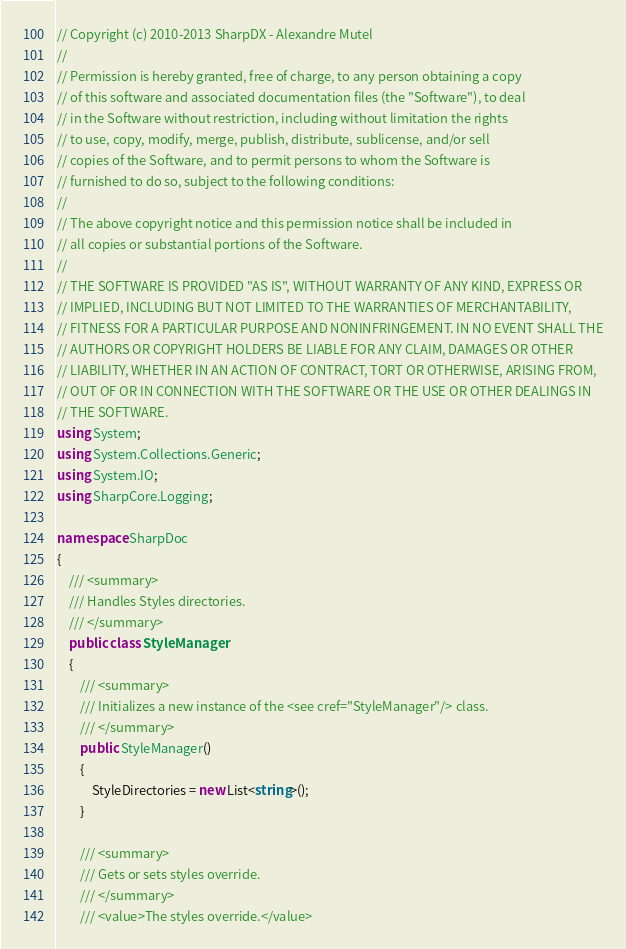Convert code to text. <code><loc_0><loc_0><loc_500><loc_500><_C#_>// Copyright (c) 2010-2013 SharpDX - Alexandre Mutel
// 
// Permission is hereby granted, free of charge, to any person obtaining a copy
// of this software and associated documentation files (the "Software"), to deal
// in the Software without restriction, including without limitation the rights
// to use, copy, modify, merge, publish, distribute, sublicense, and/or sell
// copies of the Software, and to permit persons to whom the Software is
// furnished to do so, subject to the following conditions:
// 
// The above copyright notice and this permission notice shall be included in
// all copies or substantial portions of the Software.
// 
// THE SOFTWARE IS PROVIDED "AS IS", WITHOUT WARRANTY OF ANY KIND, EXPRESS OR
// IMPLIED, INCLUDING BUT NOT LIMITED TO THE WARRANTIES OF MERCHANTABILITY,
// FITNESS FOR A PARTICULAR PURPOSE AND NONINFRINGEMENT. IN NO EVENT SHALL THE
// AUTHORS OR COPYRIGHT HOLDERS BE LIABLE FOR ANY CLAIM, DAMAGES OR OTHER
// LIABILITY, WHETHER IN AN ACTION OF CONTRACT, TORT OR OTHERWISE, ARISING FROM,
// OUT OF OR IN CONNECTION WITH THE SOFTWARE OR THE USE OR OTHER DEALINGS IN
// THE SOFTWARE.
using System;
using System.Collections.Generic;
using System.IO;
using SharpCore.Logging;

namespace SharpDoc
{
    /// <summary>
    /// Handles Styles directories.
    /// </summary>
    public class StyleManager
    {
        /// <summary>
        /// Initializes a new instance of the <see cref="StyleManager"/> class.
        /// </summary>
        public StyleManager()
        {
            StyleDirectories = new List<string>();
        }

        /// <summary>
        /// Gets or sets styles override.
        /// </summary>
        /// <value>The styles override.</value></code> 